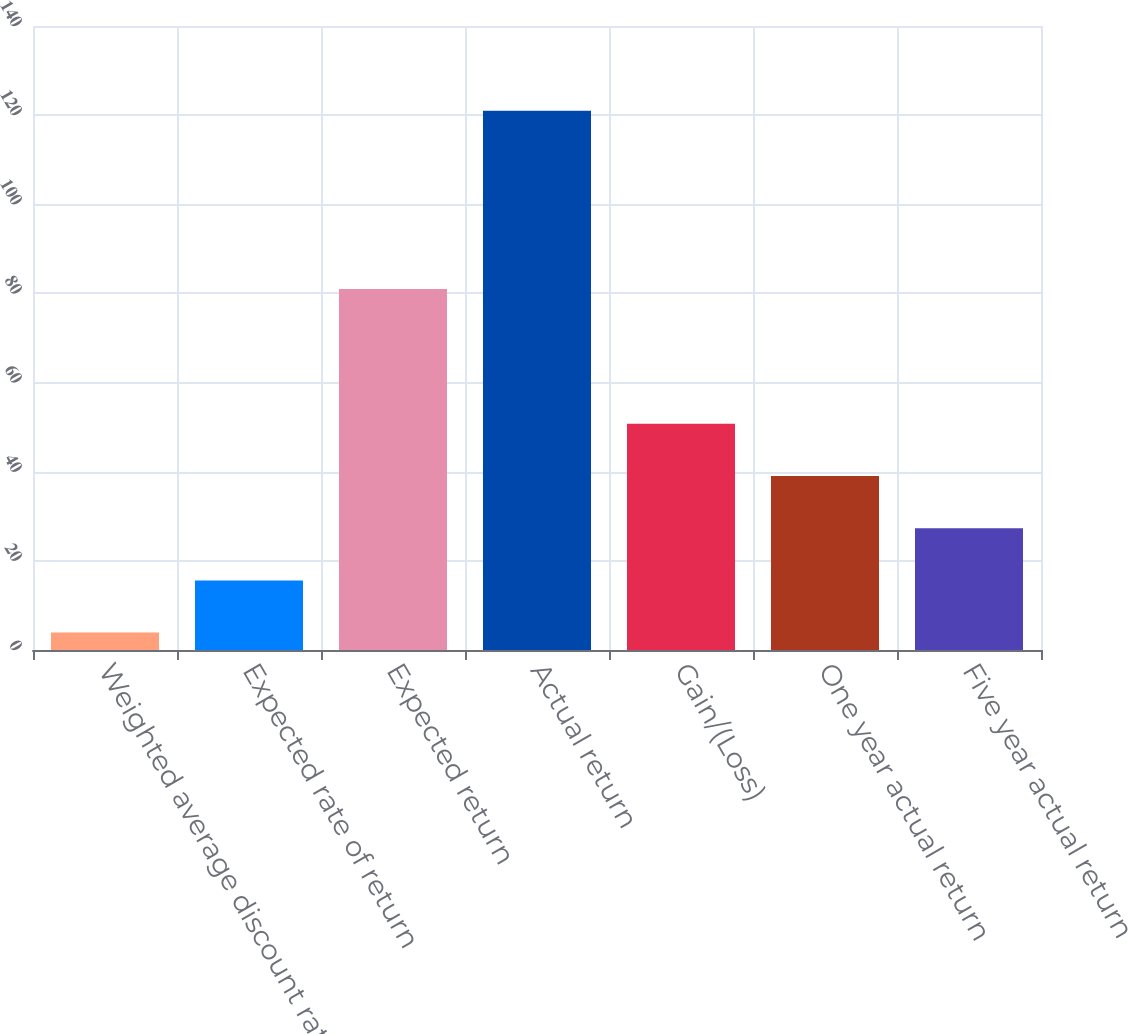<chart> <loc_0><loc_0><loc_500><loc_500><bar_chart><fcel>Weighted average discount rate<fcel>Expected rate of return<fcel>Expected return<fcel>Actual return<fcel>Gain/(Loss)<fcel>One year actual return<fcel>Five year actual return<nl><fcel>3.9<fcel>15.61<fcel>81<fcel>121<fcel>50.74<fcel>39.03<fcel>27.32<nl></chart> 